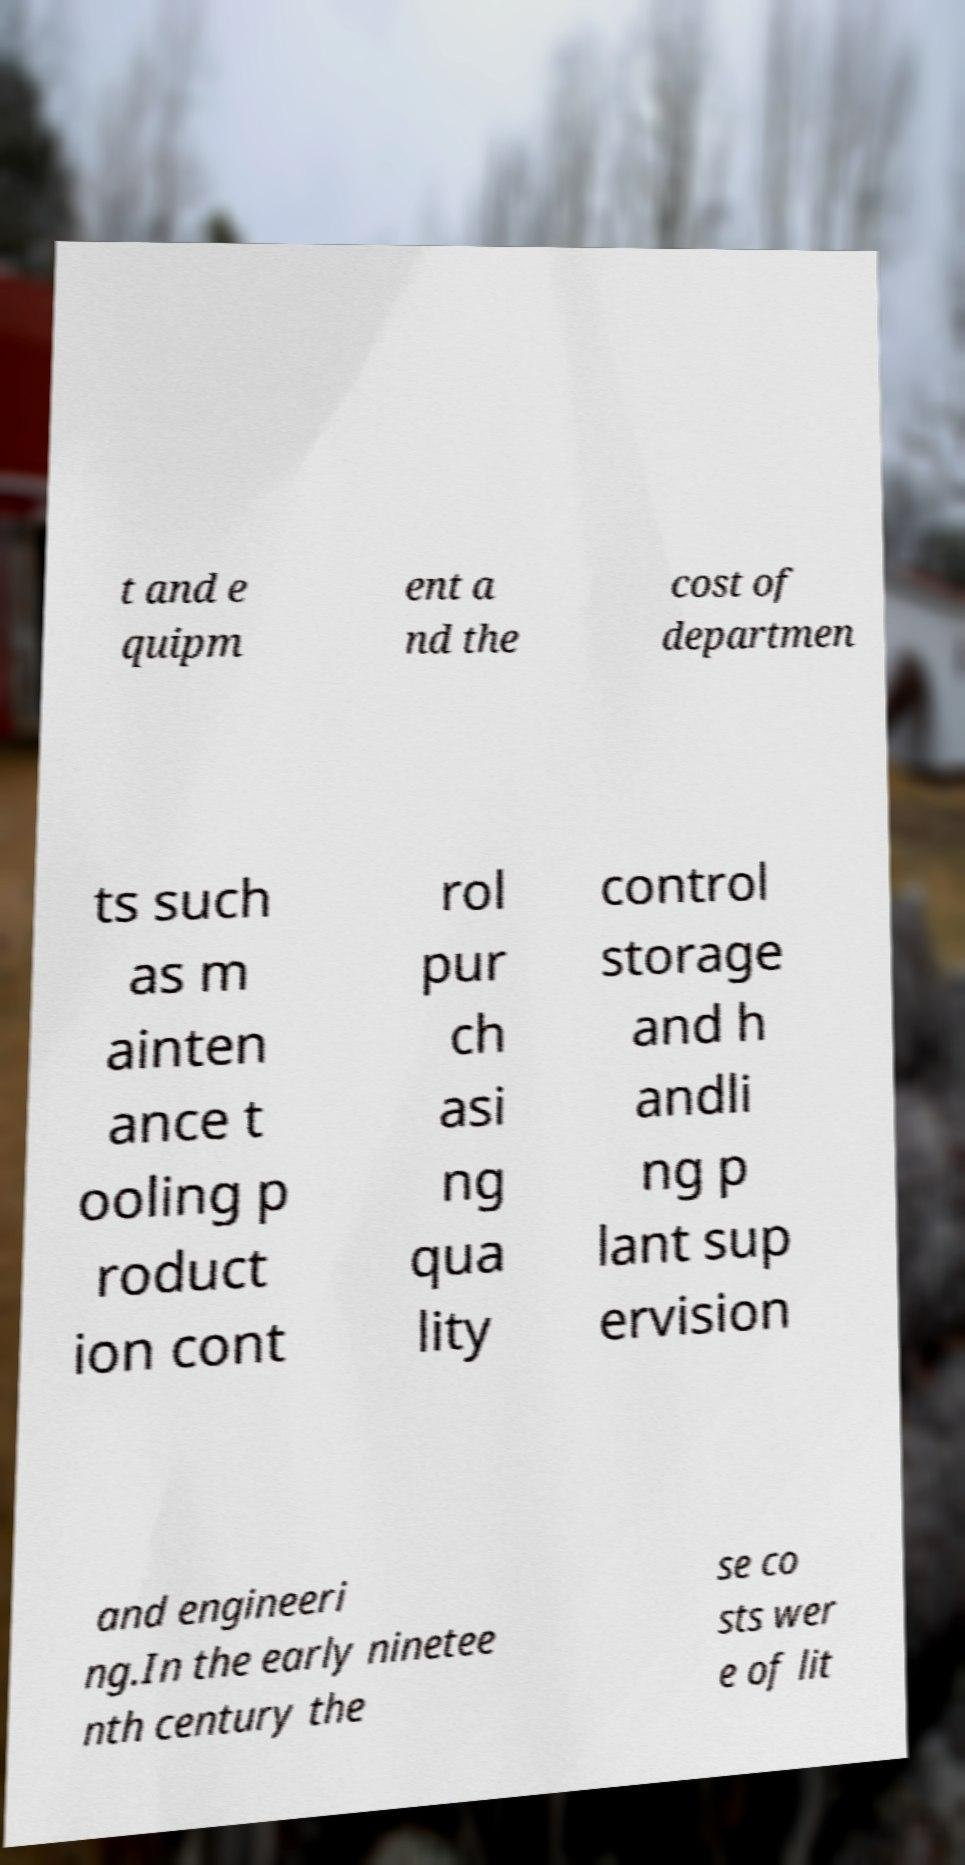Please identify and transcribe the text found in this image. t and e quipm ent a nd the cost of departmen ts such as m ainten ance t ooling p roduct ion cont rol pur ch asi ng qua lity control storage and h andli ng p lant sup ervision and engineeri ng.In the early ninetee nth century the se co sts wer e of lit 